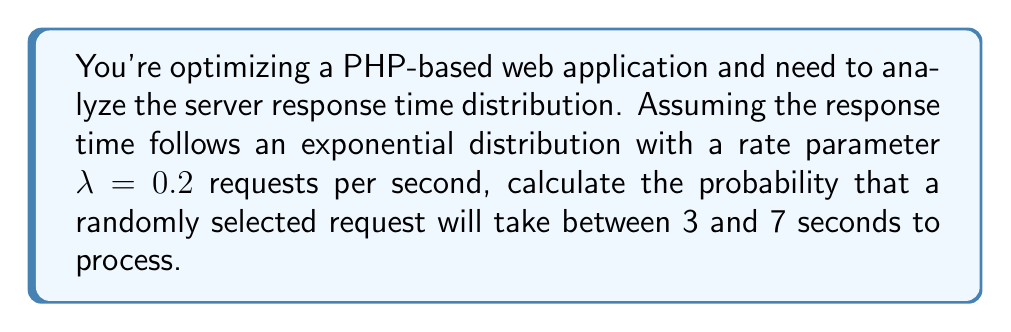Teach me how to tackle this problem. For a PHP developer focusing on practical solutions, understanding server response time distribution can help in optimizing application performance. Let's break this down step-by-step:

1) The exponential distribution's probability density function (PDF) is given by:

   $$f(x) = \lambda e^{-\lambda x}, \text{ for } x \geq 0$$

   where $\lambda$ is the rate parameter.

2) To find the probability that a request takes between 3 and 7 seconds, we need to integrate the PDF from 3 to 7:

   $$P(3 \leq X \leq 7) = \int_3^7 \lambda e^{-\lambda x} dx$$

3) Substituting $\lambda = 0.2$:

   $$P(3 \leq X \leq 7) = \int_3^7 0.2 e^{-0.2x} dx$$

4) To solve this integral, we can use the antiderivative of $e^{-ax}$, which is $-\frac{1}{a}e^{-ax}$:

   $$P(3 \leq X \leq 7) = [-e^{-0.2x}]_3^7$$

5) Evaluating the integral:

   $$P(3 \leq X \leq 7) = [-e^{-0.2(7)} - (-e^{-0.2(3)})]$$
   $$= [-e^{-1.4} - (-e^{-0.6})]$$
   $$= [-(0.2466) - (-(0.5488))]$$
   $$= -0.2466 + 0.5488$$
   $$= 0.3022$$

6) Therefore, the probability that a randomly selected request will take between 3 and 7 seconds to process is approximately 0.3022 or 30.22%.
Answer: $0.3022$ or $30.22\%$ 